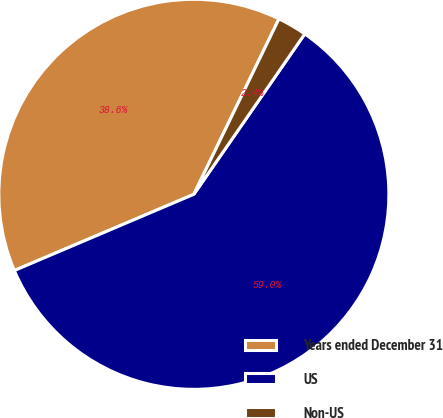Convert chart. <chart><loc_0><loc_0><loc_500><loc_500><pie_chart><fcel>Years ended December 31<fcel>US<fcel>Non-US<nl><fcel>38.58%<fcel>58.98%<fcel>2.44%<nl></chart> 